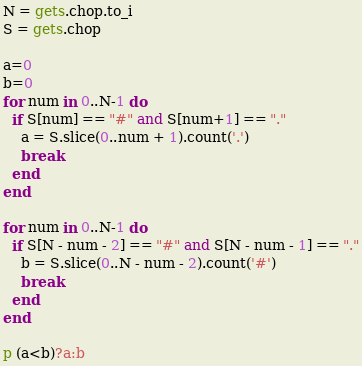Convert code to text. <code><loc_0><loc_0><loc_500><loc_500><_Ruby_>N = gets.chop.to_i
S = gets.chop

a=0
b=0
for num in 0..N-1 do
  if S[num] == "#" and S[num+1] == "."
    a = S.slice(0..num + 1).count('.')
    break
  end
end

for num in 0..N-1 do
  if S[N - num - 2] == "#" and S[N - num - 1] == "."
    b = S.slice(0..N - num - 2).count('#')
    break
  end
end

p (a<b)?a:b</code> 